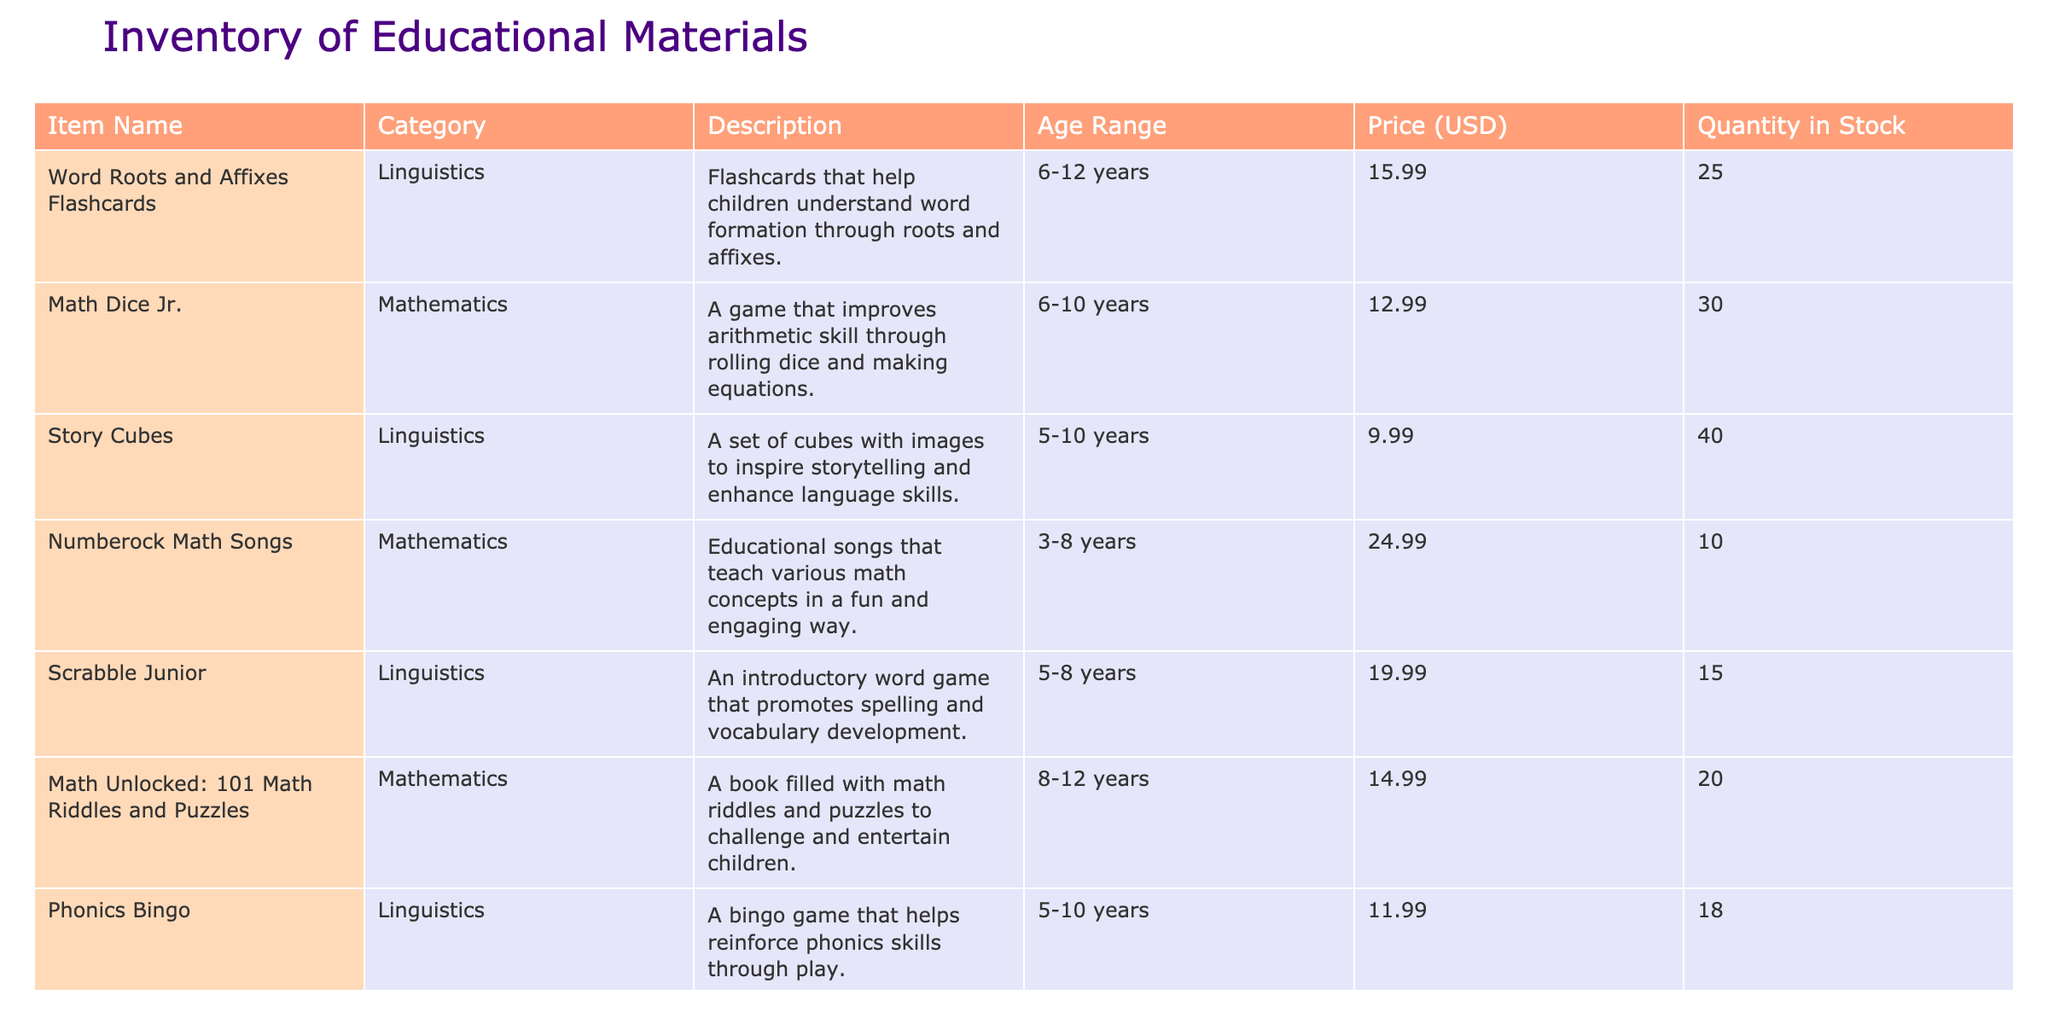What is the price of "Phonics Bingo"? The price of "Phonics Bingo" is listed in the Price (USD) column next to the item. It states 11.99 USD.
Answer: 11.99 USD How many units of "Math Dice Jr." are in stock? Referring to the Quantity in Stock column for "Math Dice Jr.", it shows there are 30 units available.
Answer: 30 What is the age range for "Exploring Language Structure"? The age range can be found in the Age Range column next to "Exploring Language Structure", which indicates it is suitable for 8-12 years.
Answer: 8-12 years Which educational material has the highest price? By comparing the prices across all items in the Price (USD) column, "Numberock Math Songs" has the highest price at 24.99 USD.
Answer: Numberock Math Songs What is the total quantity in stock for all linguistics items? First, identify the linguistics items: "Word Roots and Affixes Flashcards" (25), "Story Cubes" (40), "Scrabble Junior" (15), "Phonics Bingo" (18), and "Exploring Language Structure" (22). Summing these gives: 25 + 40 + 15 + 18 + 22 = 120.
Answer: 120 Is "GeoBoard Starter Kit" targeted for children under 7 years old? Checking the Age Range for the "GeoBoard Starter Kit," it specifies 7-12 years, indicating it is not suitable for children under 7.
Answer: No What is the average price of all educational materials? First, sum the prices: 15.99 + 12.99 + 9.99 + 24.99 + 19.99 + 14.99 + 11.99 + 29.99 + 16.99 + 14.99 =  156.90. There are 10 items, so the average is 156.90 / 10 = 15.69.
Answer: 15.69 How many more units of "Math Unlocked: 101 Math Riddles and Puzzles" are there compared to "Numberock Math Songs"? The stock for "Math Unlocked: 101 Math Riddles and Puzzles" is 20, and for "Numberock Math Songs," it's 10. The difference is 20 - 10 = 10 units more for "Math Unlocked."
Answer: 10 more units Are there more linguistic items than mathematical ones in stock? Counting the quantity of linguistics items: 25 + 40 + 15 + 18 + 22 = 120. For math items: 30 + 10 + 20 + 12 + 15 = 87. Since 120 > 87, there are more linguistics items in stock.
Answer: Yes 